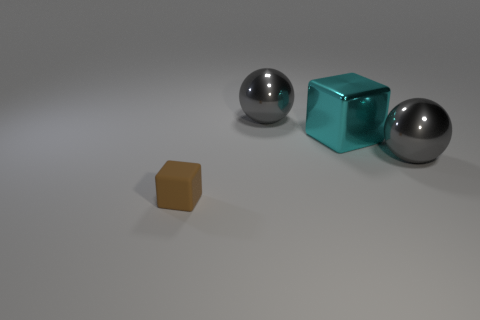Is the shape of the gray object that is on the right side of the large cyan shiny thing the same as  the brown rubber object?
Your response must be concise. No. Is there a large cyan shiny thing that is behind the gray shiny ball that is right of the big cyan shiny thing?
Keep it short and to the point. Yes. What number of blocks are there?
Make the answer very short. 2. What color is the object that is both in front of the large cyan cube and behind the small brown thing?
Provide a succinct answer. Gray. The cyan metallic thing that is the same shape as the small matte thing is what size?
Offer a terse response. Large. How many gray things have the same size as the shiny cube?
Keep it short and to the point. 2. What is the cyan object made of?
Your response must be concise. Metal. Are there any tiny brown rubber cubes right of the small brown thing?
Your response must be concise. No. What number of big shiny blocks are the same color as the matte cube?
Make the answer very short. 0. Is the number of small brown rubber cubes that are in front of the brown thing less than the number of cyan shiny cubes that are to the left of the cyan metal block?
Make the answer very short. No. 